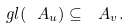<formula> <loc_0><loc_0><loc_500><loc_500>\ g l ( \ A _ { u } ) \subseteq \ A _ { v } .</formula> 